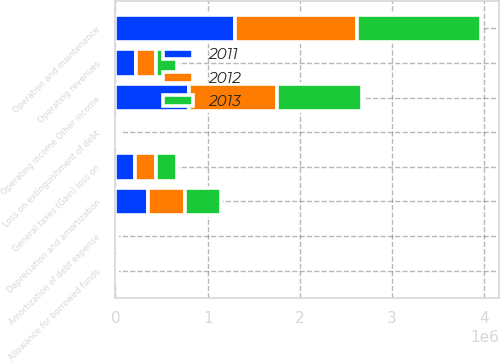Convert chart. <chart><loc_0><loc_0><loc_500><loc_500><stacked_bar_chart><ecel><fcel>Operating revenues<fcel>Operation and maintenance<fcel>Depreciation and amortization<fcel>General taxes (Gain) loss on<fcel>Operating income Other income<fcel>Loss on extinguishment of debt<fcel>Allowance for borrowed funds<fcel>Amortization of debt expense<nl><fcel>2012<fcel>221212<fcel>1.31272e+06<fcel>407718<fcel>234642<fcel>945849<fcel>12639<fcel>6377<fcel>6603<nl><fcel>2013<fcel>221212<fcel>1.35004e+06<fcel>381503<fcel>221212<fcel>924973<fcel>15592<fcel>7771<fcel>5358<nl><fcel>2011<fcel>221212<fcel>1.30179e+06<fcel>351821<fcel>210478<fcel>803136<fcel>13131<fcel>5923<fcel>5055<nl></chart> 